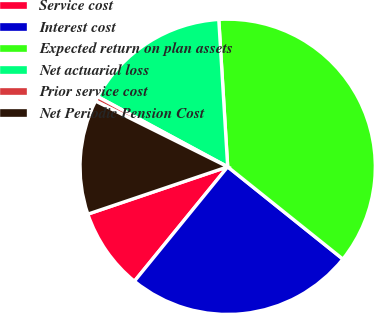Convert chart. <chart><loc_0><loc_0><loc_500><loc_500><pie_chart><fcel>Service cost<fcel>Interest cost<fcel>Expected return on plan assets<fcel>Net actuarial loss<fcel>Prior service cost<fcel>Net Periodic Pension Cost<nl><fcel>8.92%<fcel>25.13%<fcel>36.71%<fcel>16.16%<fcel>0.53%<fcel>12.54%<nl></chart> 